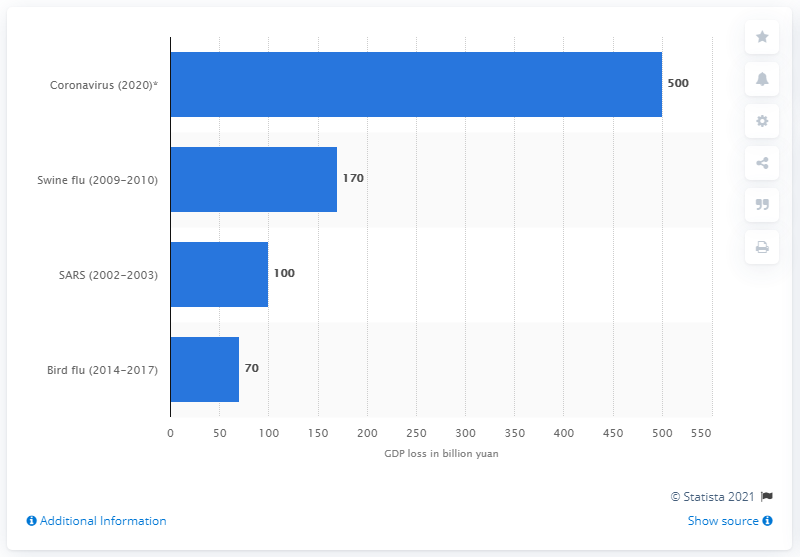Draw attention to some important aspects in this diagram. How much could China's GDP potentially lose in 2020? The estimate is approximately 500 million dollars. 